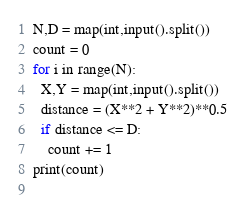Convert code to text. <code><loc_0><loc_0><loc_500><loc_500><_Python_>N,D = map(int,input().split())
count = 0
for i in range(N):
  X,Y = map(int,input().split())
  distance = (X**2 + Y**2)**0.5
  if distance <= D:
    count += 1
print(count)
    </code> 